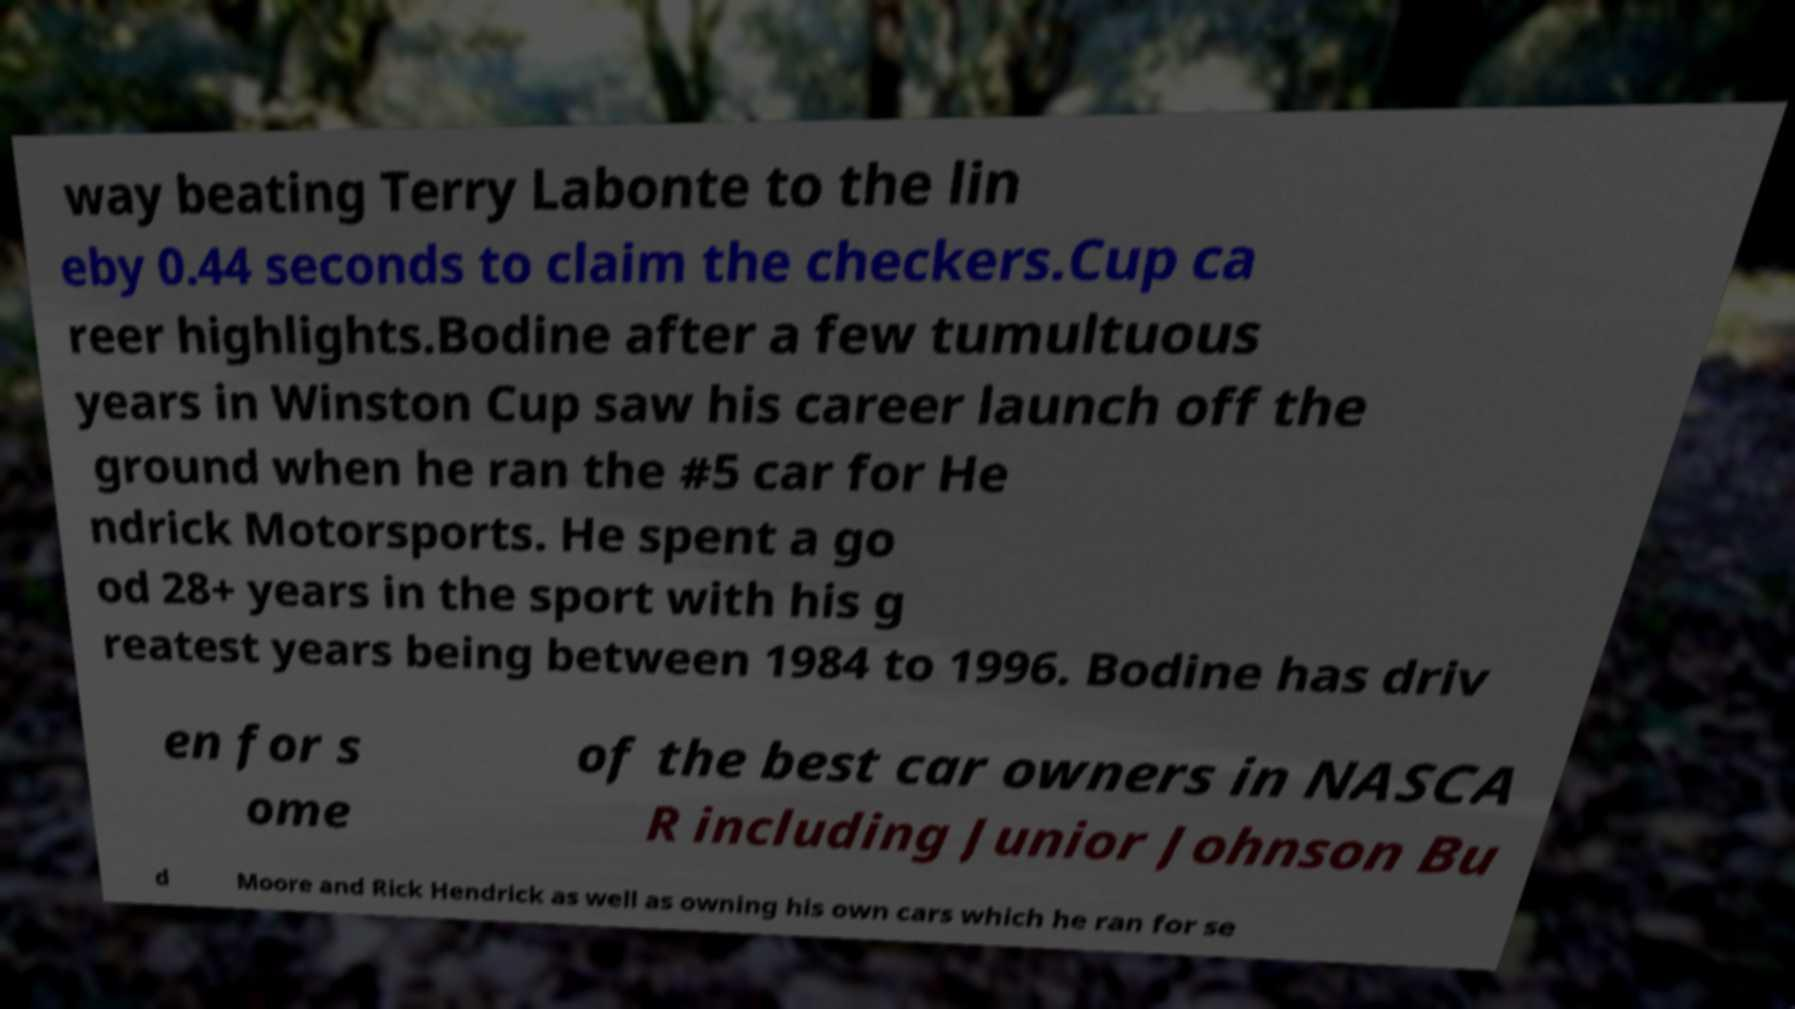Could you assist in decoding the text presented in this image and type it out clearly? way beating Terry Labonte to the lin eby 0.44 seconds to claim the checkers.Cup ca reer highlights.Bodine after a few tumultuous years in Winston Cup saw his career launch off the ground when he ran the #5 car for He ndrick Motorsports. He spent a go od 28+ years in the sport with his g reatest years being between 1984 to 1996. Bodine has driv en for s ome of the best car owners in NASCA R including Junior Johnson Bu d Moore and Rick Hendrick as well as owning his own cars which he ran for se 